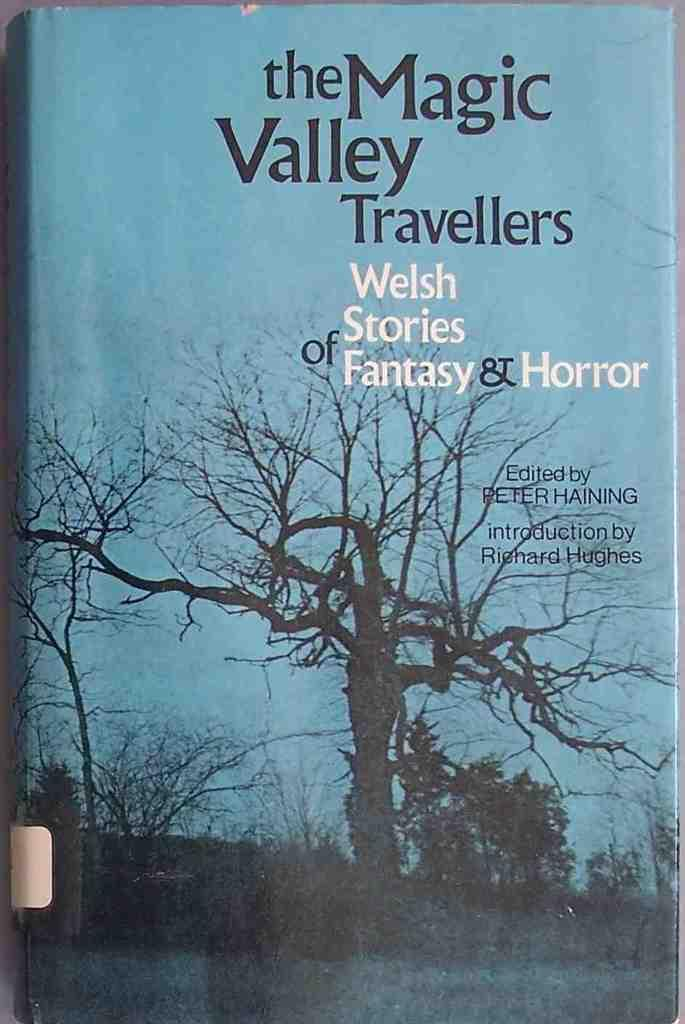Provide a one-sentence caption for the provided image. A book called the Magic Valley Travellers that has Welsh stories of Fantasy and Horror.. 